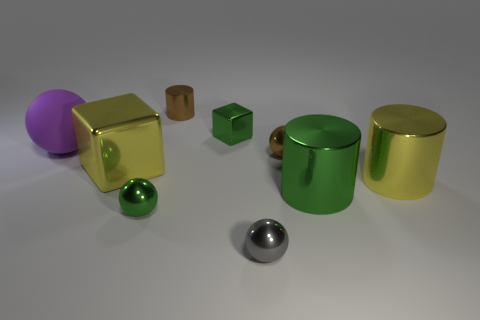Is there a tiny brown ball that is left of the large yellow metallic object that is behind the large yellow metallic cylinder?
Keep it short and to the point. No. What color is the sphere that is to the right of the purple matte ball and behind the big yellow shiny cylinder?
Give a very brief answer. Brown. Are there any small gray metal spheres behind the big yellow object that is on the right side of the green metal thing left of the tiny green cube?
Your answer should be very brief. No. The brown metal thing that is the same shape as the rubber object is what size?
Provide a succinct answer. Small. Is there any other thing that has the same material as the brown ball?
Offer a very short reply. Yes. Is there a large yellow thing?
Your answer should be compact. Yes. There is a large ball; does it have the same color as the metal cube that is behind the big matte ball?
Provide a succinct answer. No. There is a green metal object that is to the right of the tiny metallic ball that is behind the cube that is in front of the green cube; what is its size?
Offer a terse response. Large. How many metallic spheres are the same color as the tiny cylinder?
Make the answer very short. 1. How many objects are big red cubes or balls that are on the right side of the big purple rubber thing?
Your answer should be very brief. 3. 